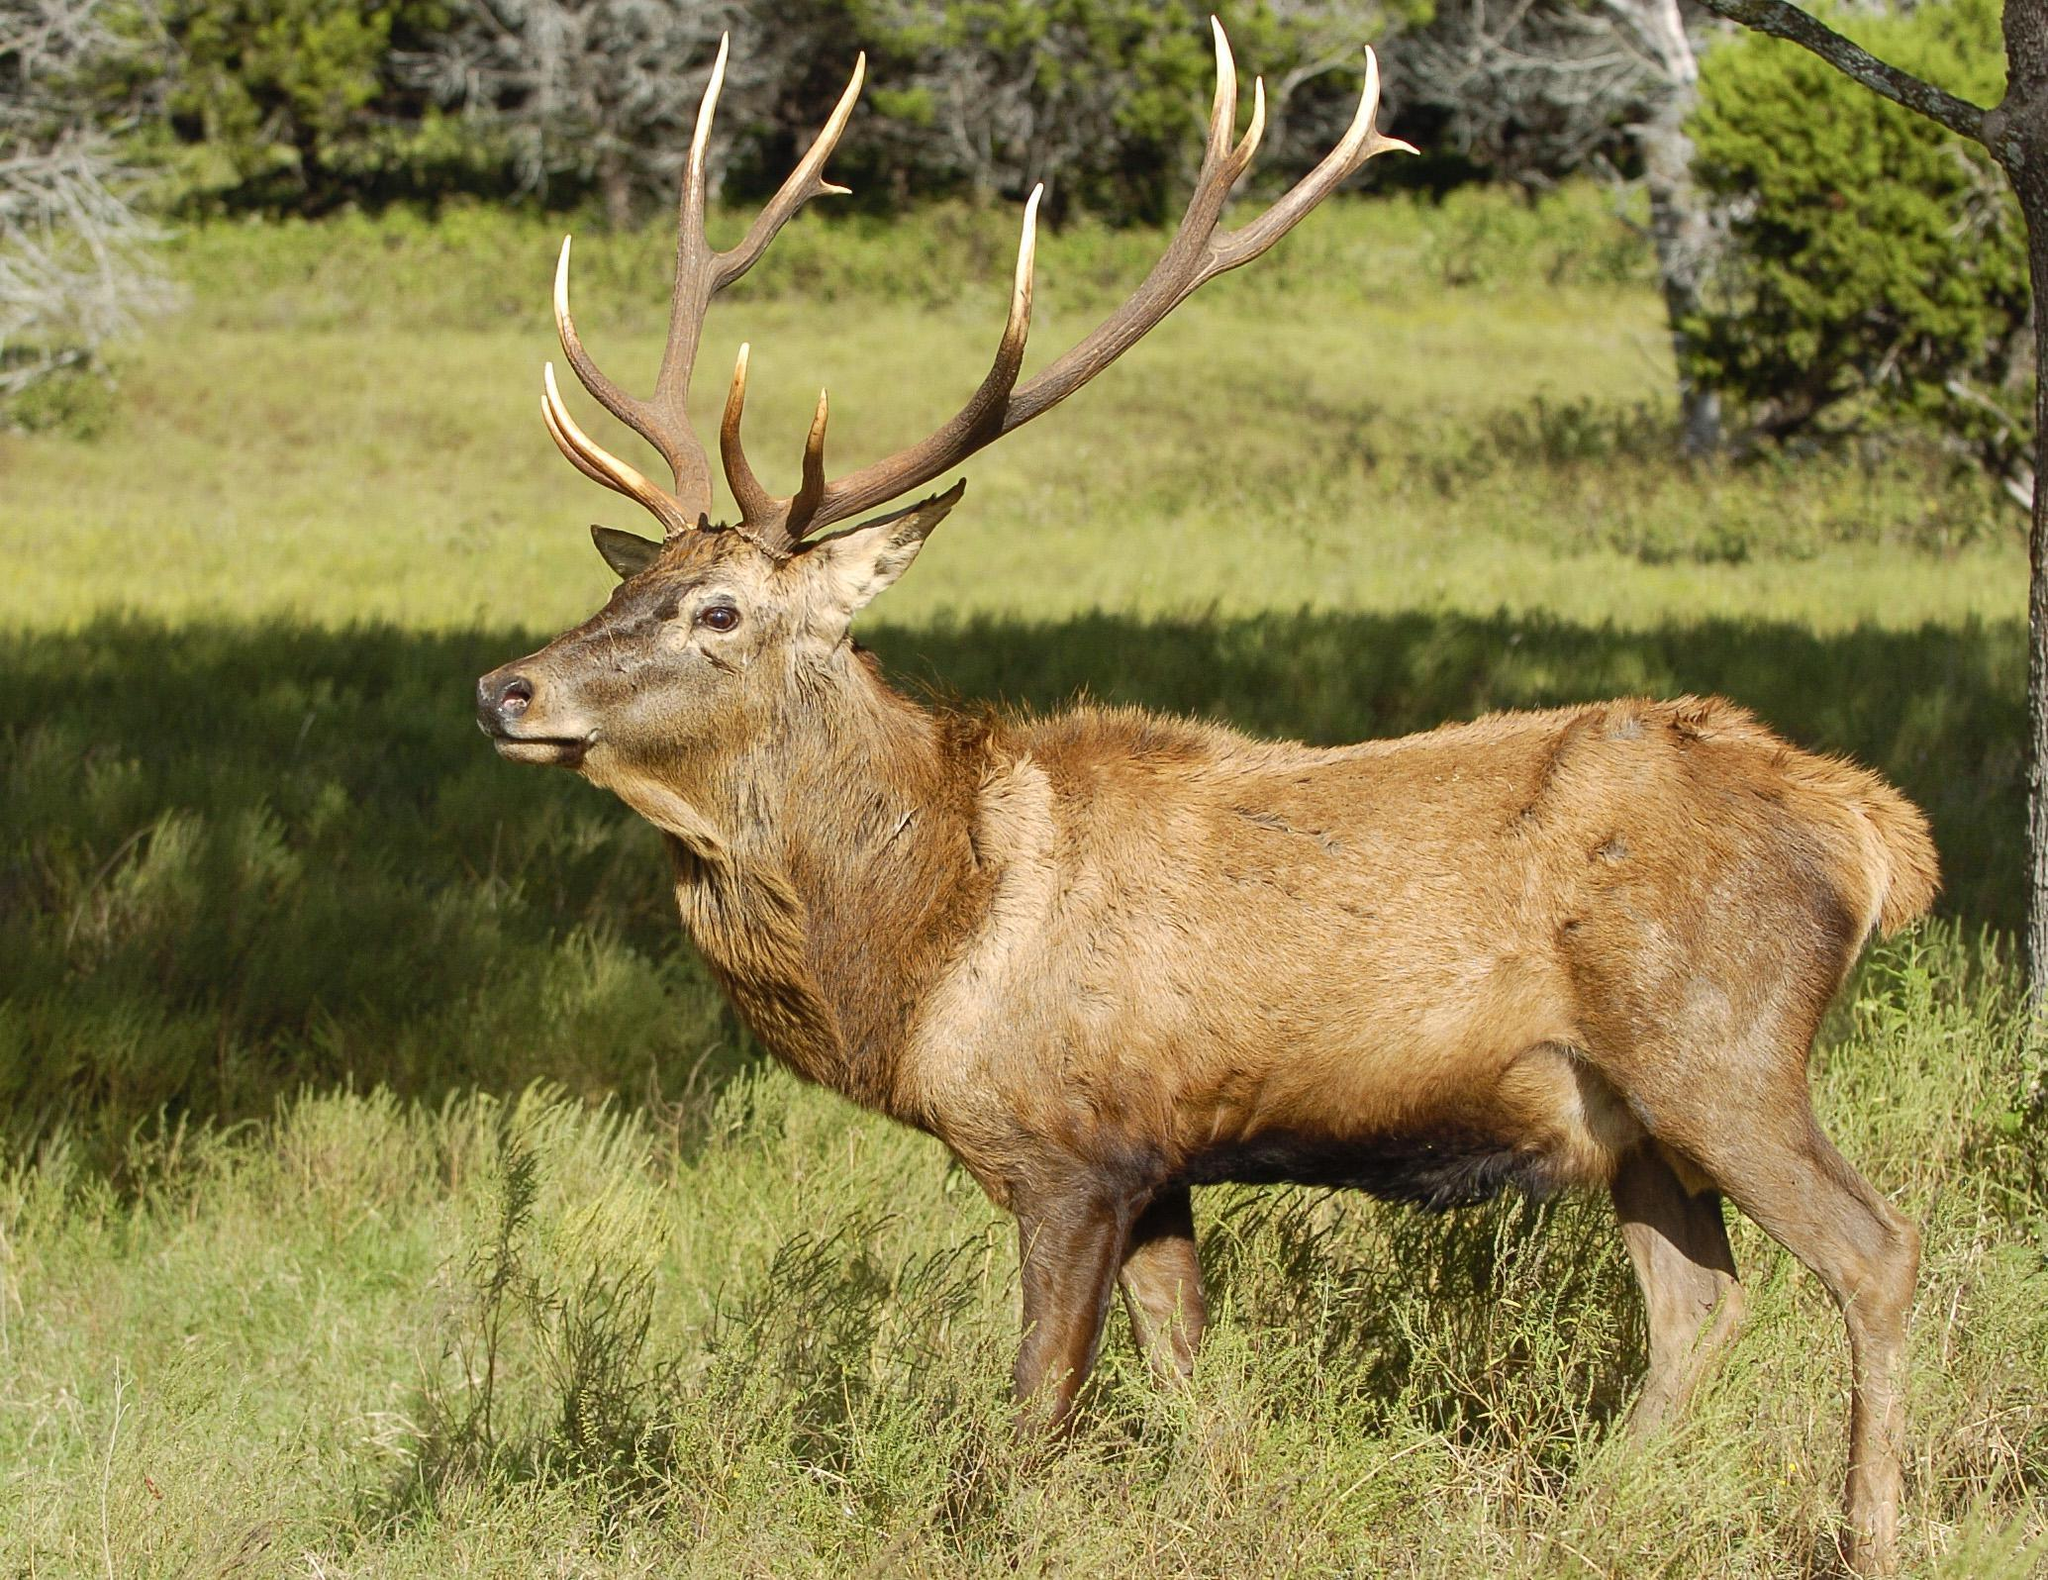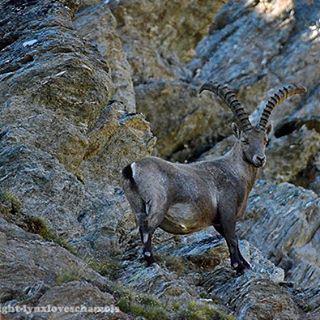The first image is the image on the left, the second image is the image on the right. Examine the images to the left and right. Is the description "An image shows one horned animal standing on dark rocks." accurate? Answer yes or no. Yes. The first image is the image on the left, the second image is the image on the right. Examine the images to the left and right. Is the description "The mountain goat in the right image is standing on a steep rocky mountain." accurate? Answer yes or no. Yes. 